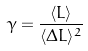Convert formula to latex. <formula><loc_0><loc_0><loc_500><loc_500>\gamma = \frac { \langle L \rangle } { \langle \Delta L \rangle ^ { 2 } }</formula> 